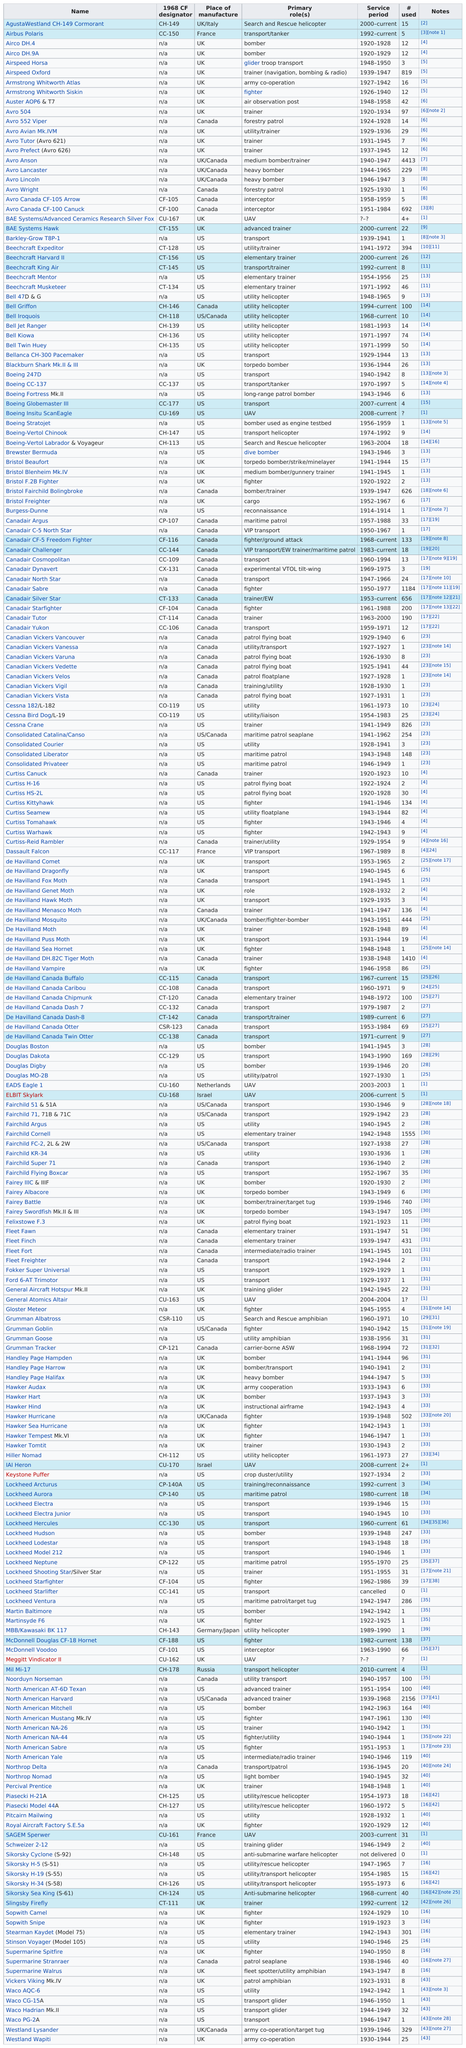Outline some significant characteristics in this image. Bell Griffons are an important part of the military and are in service. At least 100 Bell Griffons are currently operational. The Bristol F.2B fighter was the only aircraft besides the Fairchild Argus that was in service with only two examples. The Hawker Hind had more in service than the Hawker Hart. The United Kingdom or the United States manufactured the most Canadian Air Force planes. There were more Avro 504s or Douglas Digbys? The Avro 504... 